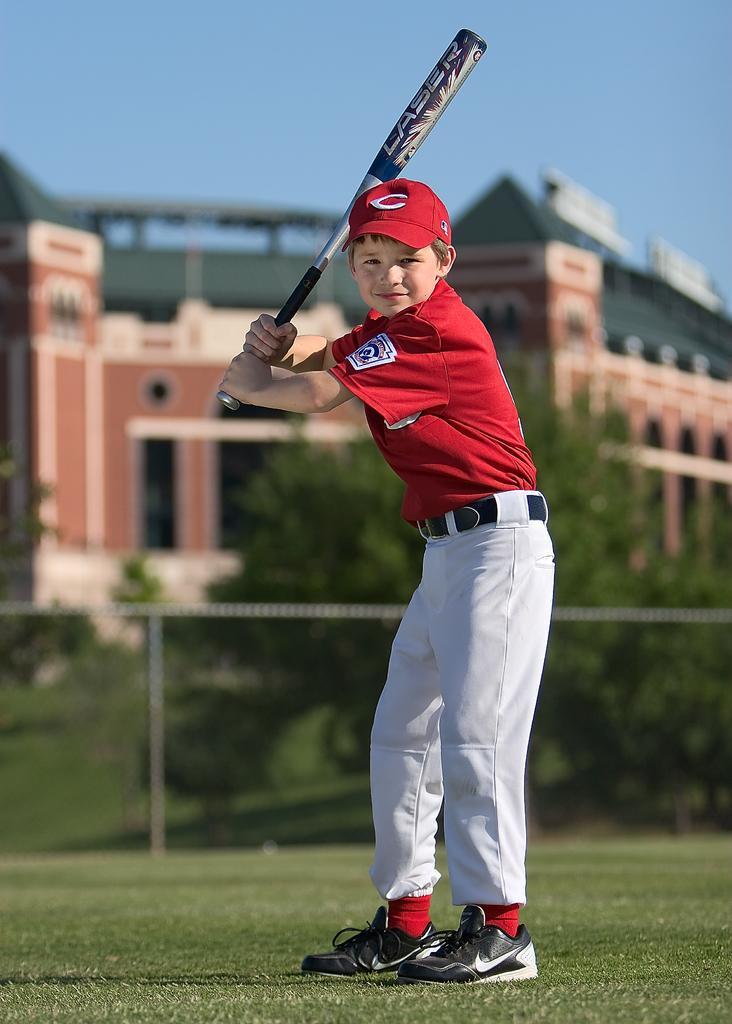Can you describe this image briefly? In this picture there is a boy standing and holding the bat. At the back there is a building and there are trees and there is a fence. At the top there is sky. At the bottom there is grass. 